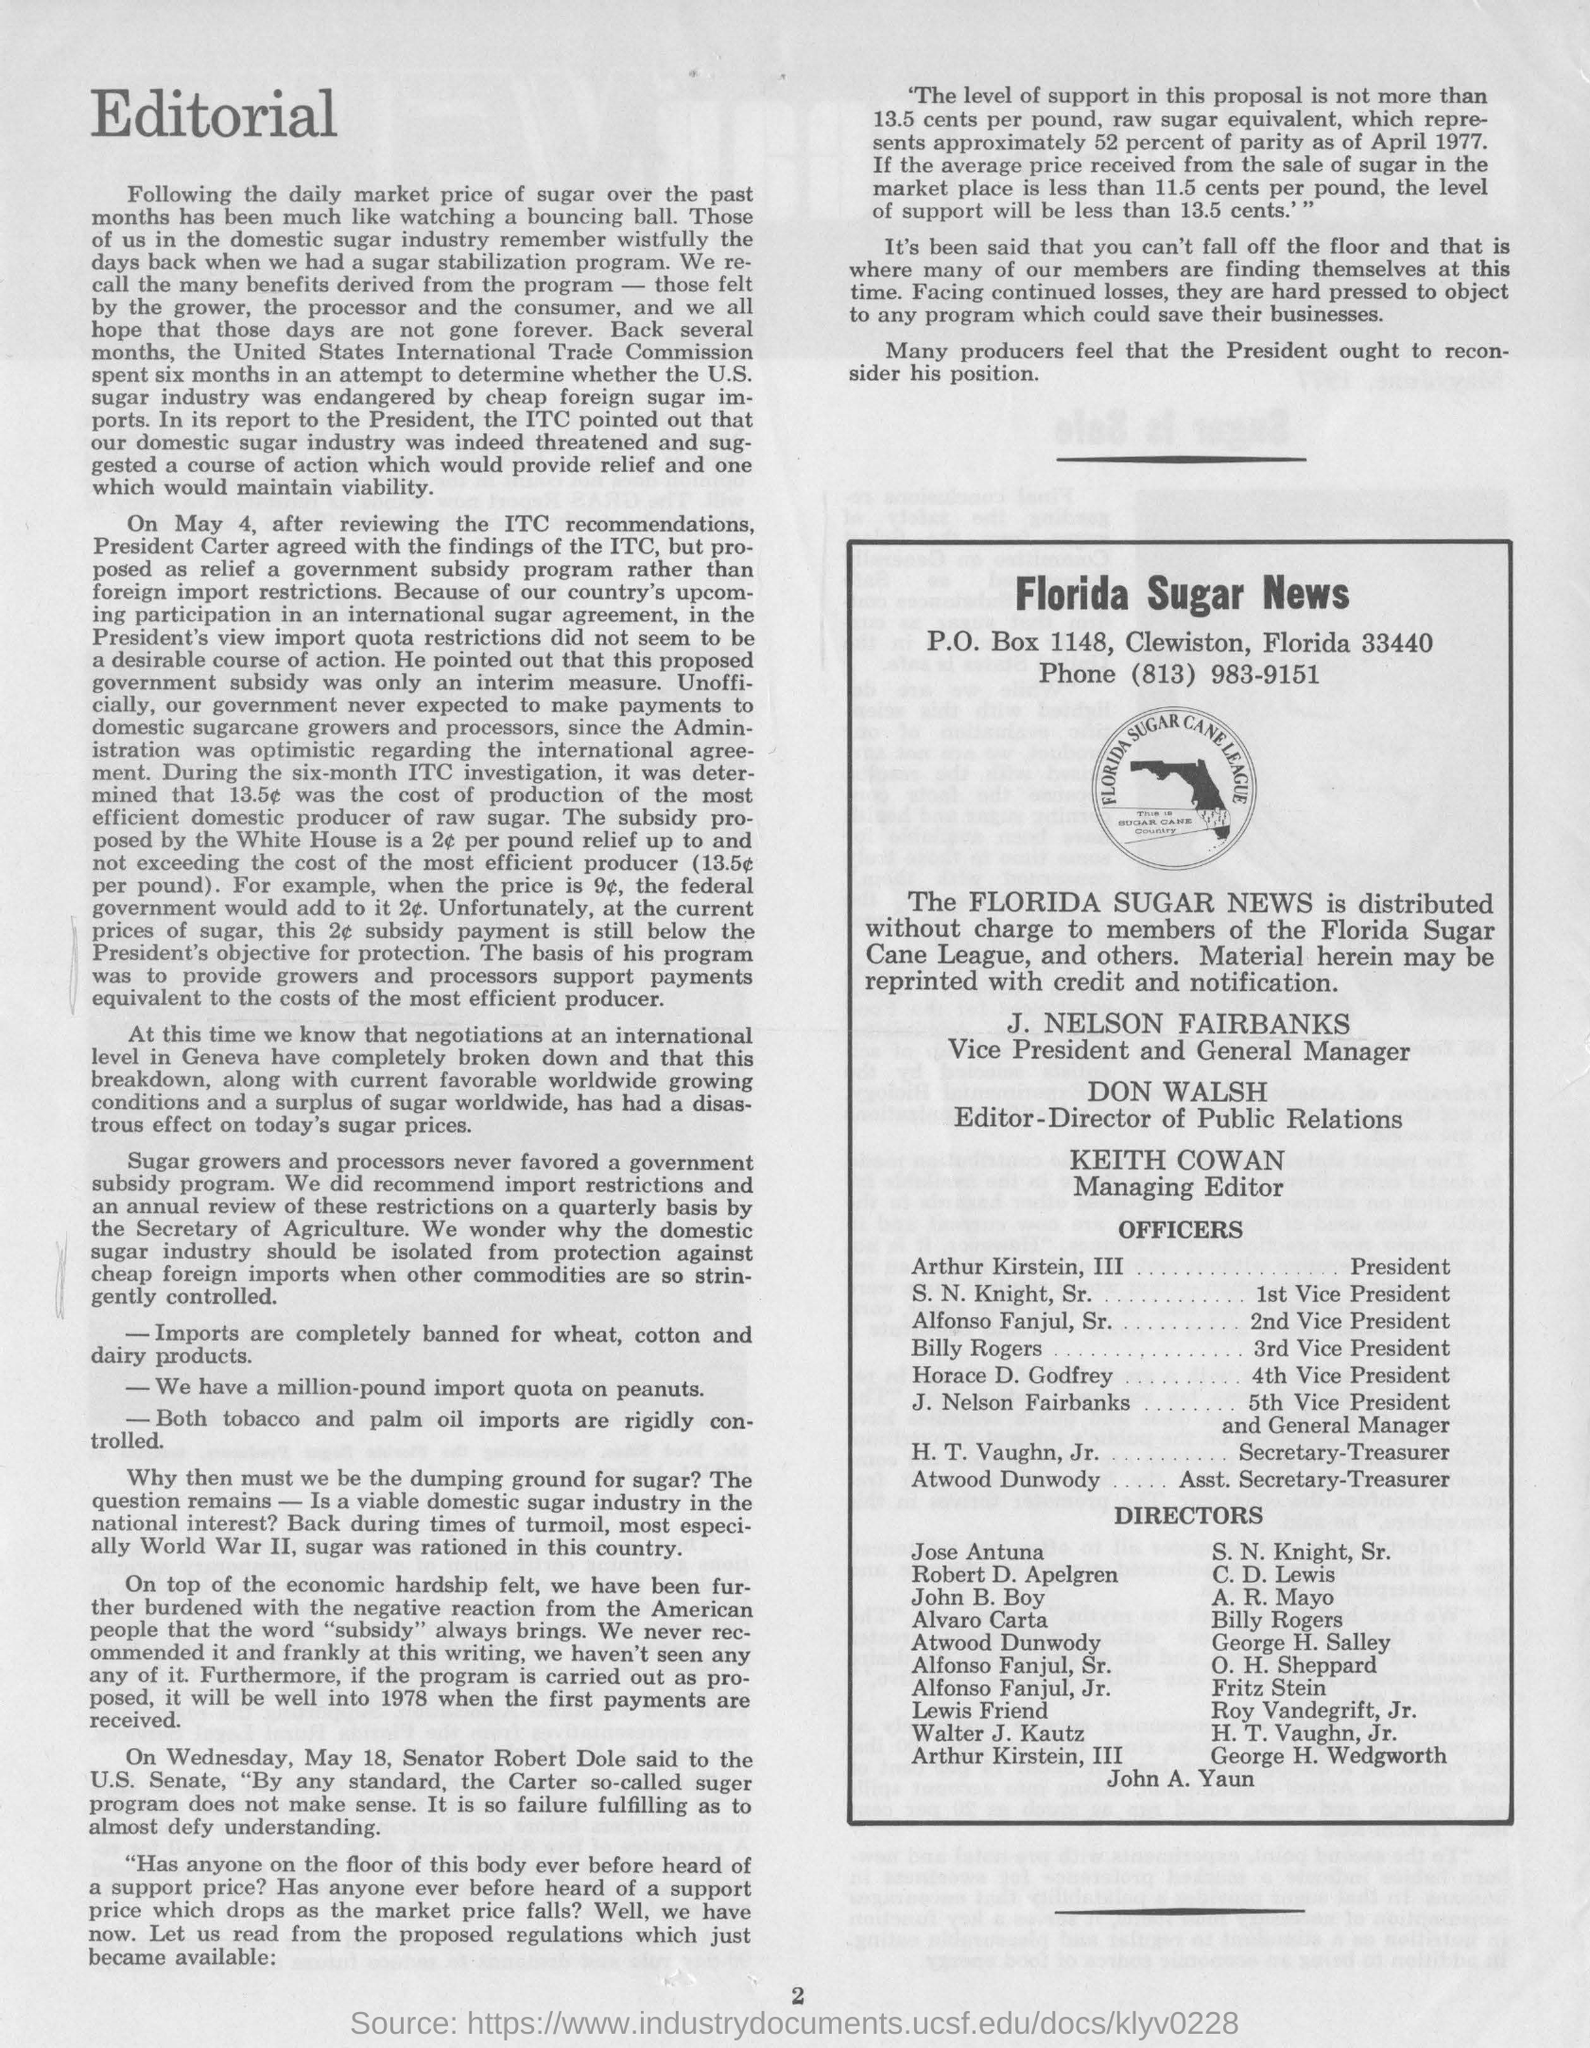Draw attention to some important aspects in this diagram. The news mentioned is called "Florida Sugar. The phone number mentioned is (813) 983-9151. The name of the managing editor mentioned is Keith Cowan. The vice president and general manager mentioned is J. Nelson Fairbanks. Don Walsh is the editor-director of public relations. 